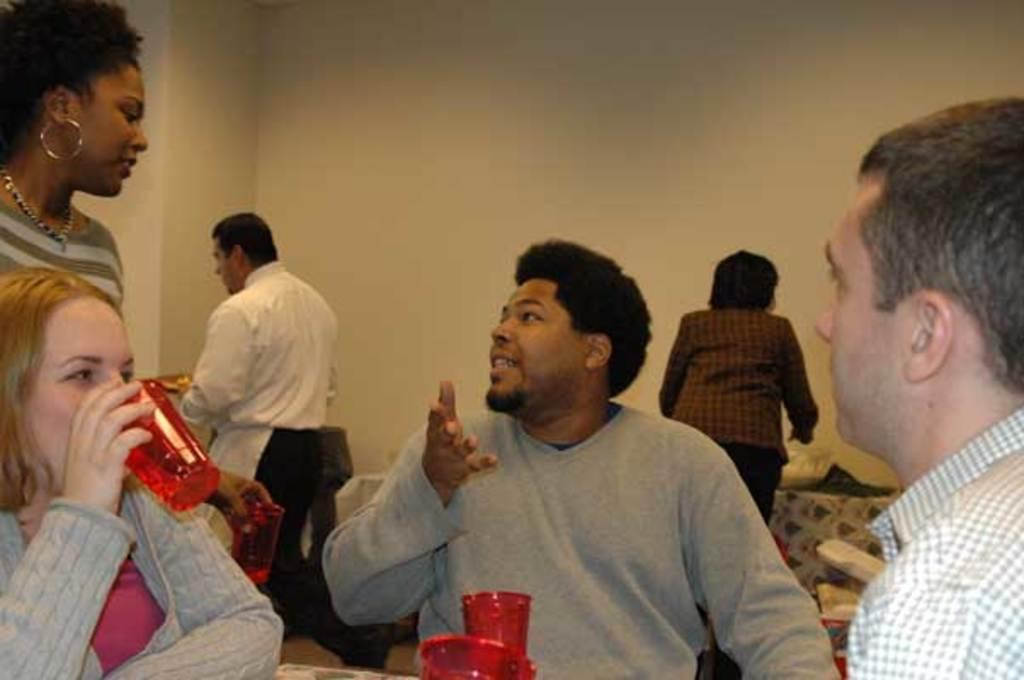How would you summarize this image in a sentence or two? In this image I can see there are three people sitting on the cars, there are few other persons in the background and there is a wall. 